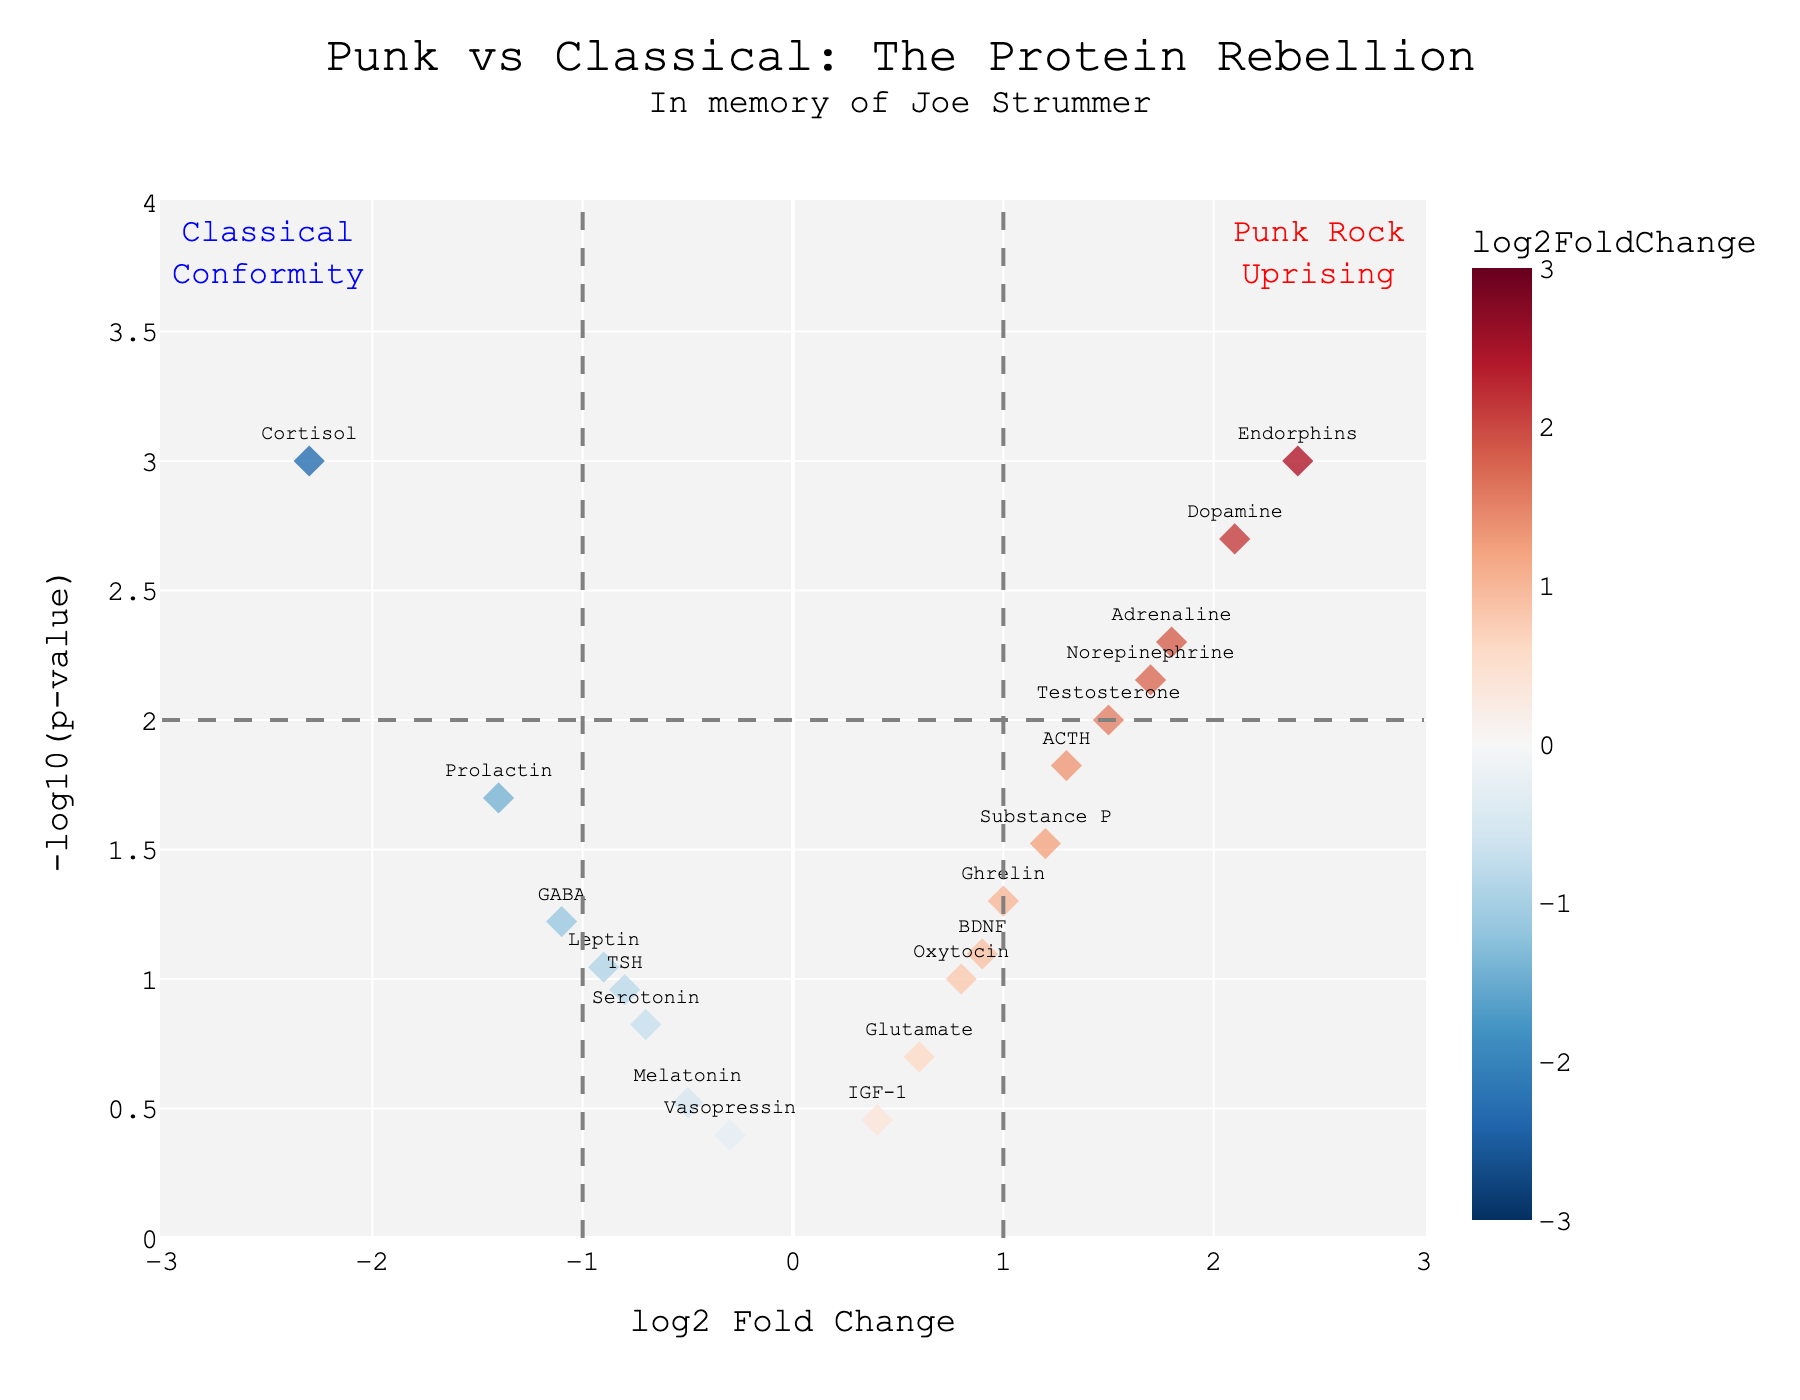what is the title of the Volcano Plot? The title is prominently displayed at the top center of the plot and reads, "Punk vs Classical: The Protein Rebellion" followed by a subtitle "In memory of Joe Strummer"
Answer: Punk vs Classical: The Protein Rebellion Which protein has the lowest log2 Fold Change? To determine the protein with the lowest log2 Fold Change, look at the x-axis and find the point that is farthest to the left (-2.3). The label indicates that this protein is Cortisol
Answer: Cortisol What is the maximum -log10(p-value) in the plot, and which protein does it correspond to? Identify the highest point on the y-axis of the plot, which represents the maximum -log10(p-value). This point corresponds to around 3 and matches the protein Endorphins
Answer: 3, Endorphins How many proteins have a negative log2 Fold Change? Count the number of data points to the left of the y-axis where log2 Fold Change is negative. The proteins are Cortisol, Serotonin, GABA, Melatonin, Vasopressin, Prolactin, Leptin, and TSH, making the total eight
Answer: 8 For which protein is the change in expression least statistically significant? Look for the smallest -log10(p-value) value on the plot, which would be a point closest to the x-axis. This corresponds to Vasopressin with a pValue of 0.4
Answer: Vasopressin What range of log2 Fold Change values is visually emphasized using different colors? Note the color bar on the right side of the plot. It ranges from -3 to 3, indicating that the color scale covers log2 Fold Change values in this range
Answer: -3 to 3 Between Adrenaline and Dopamine, which protein shows a higher log2 Fold Change? Verify the x-axis positions for Adrenaline (1.8) and Dopamine (2.1). Dopamine is farther to the right, indicating a higher log2 Fold Change
Answer: Dopamine Compare the statistical significance of Norepinephrine and Ghrelin in terms of p-value. Which one is more statistically significant? Use the -log10(p-value) which inversely indicates statistical significance. Norepinephrine is at ~2.15, while Ghrelin is at 1.3, showing Norepinephrine is more statistically significant
Answer: Norepinephrine Which proteins fall into the category labeled as "Punk Rock Uprising"? The annotation "Punk Rock Uprising" is on the upper-right area. Data points in this area (log2 Fold Change > 1 and -log10(p-value) > 2) include Endorphins, Dopamine, Norepinephrine, Adrenaline, and ACTH
Answer: Endorphins, Dopamine, Norepinephrine, Adrenaline, ACTH 